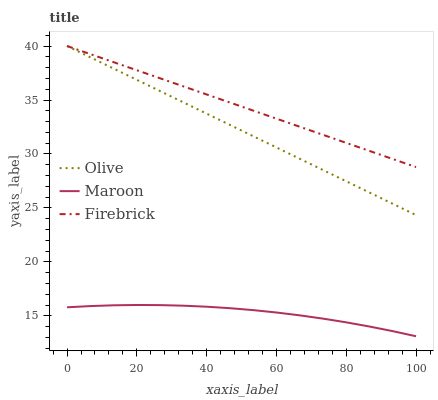Does Firebrick have the minimum area under the curve?
Answer yes or no. No. Does Maroon have the maximum area under the curve?
Answer yes or no. No. Is Firebrick the smoothest?
Answer yes or no. No. Is Firebrick the roughest?
Answer yes or no. No. Does Firebrick have the lowest value?
Answer yes or no. No. Does Maroon have the highest value?
Answer yes or no. No. Is Maroon less than Firebrick?
Answer yes or no. Yes. Is Firebrick greater than Maroon?
Answer yes or no. Yes. Does Maroon intersect Firebrick?
Answer yes or no. No. 